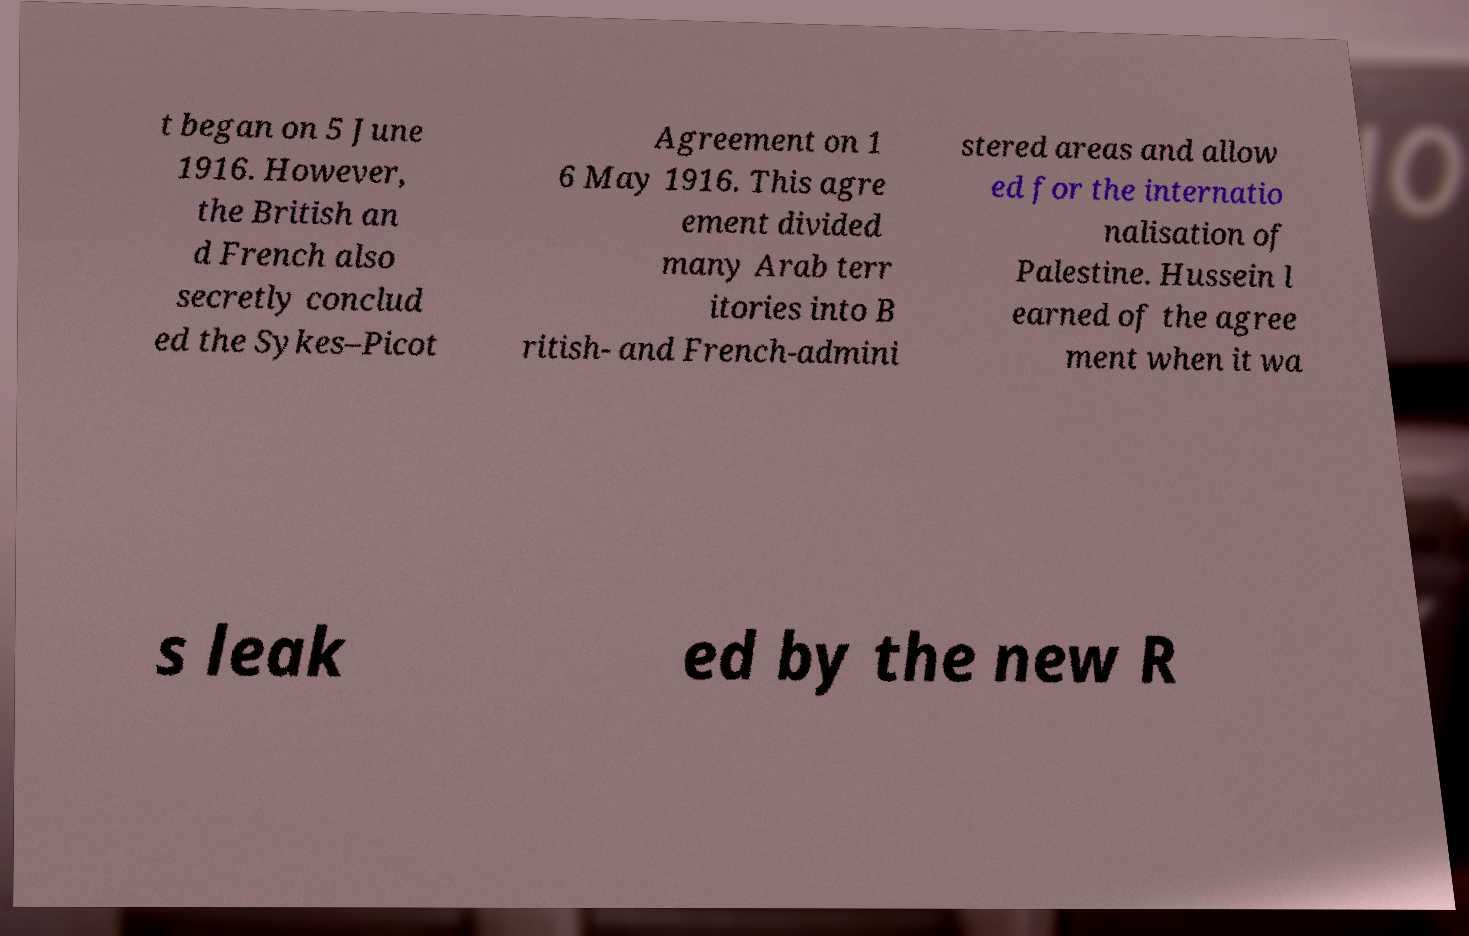Please read and relay the text visible in this image. What does it say? t began on 5 June 1916. However, the British an d French also secretly conclud ed the Sykes–Picot Agreement on 1 6 May 1916. This agre ement divided many Arab terr itories into B ritish- and French-admini stered areas and allow ed for the internatio nalisation of Palestine. Hussein l earned of the agree ment when it wa s leak ed by the new R 